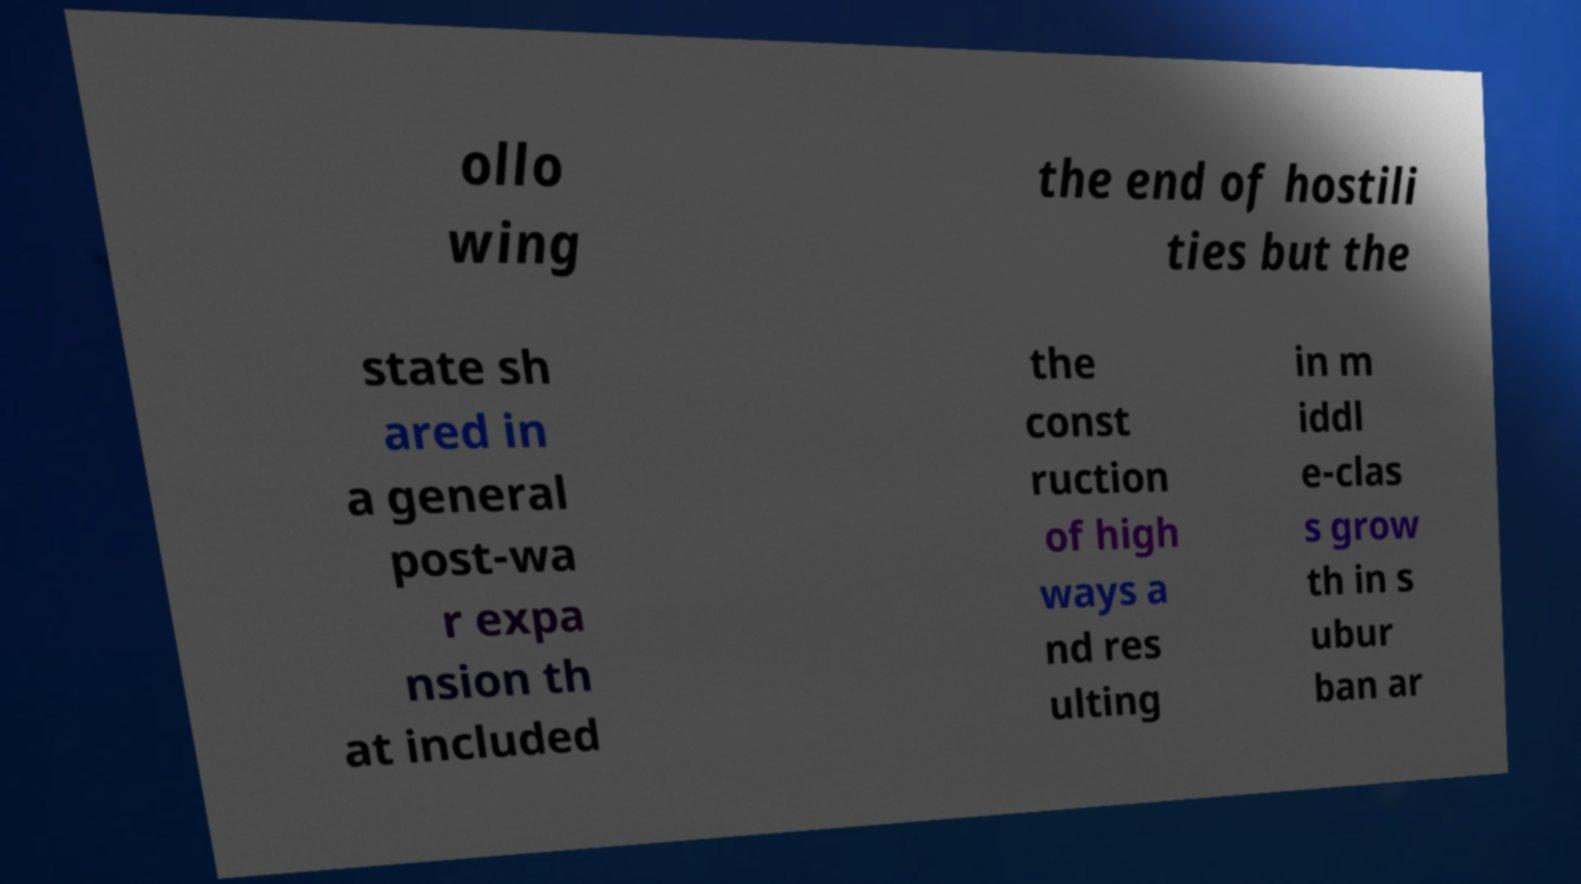Please read and relay the text visible in this image. What does it say? ollo wing the end of hostili ties but the state sh ared in a general post-wa r expa nsion th at included the const ruction of high ways a nd res ulting in m iddl e-clas s grow th in s ubur ban ar 